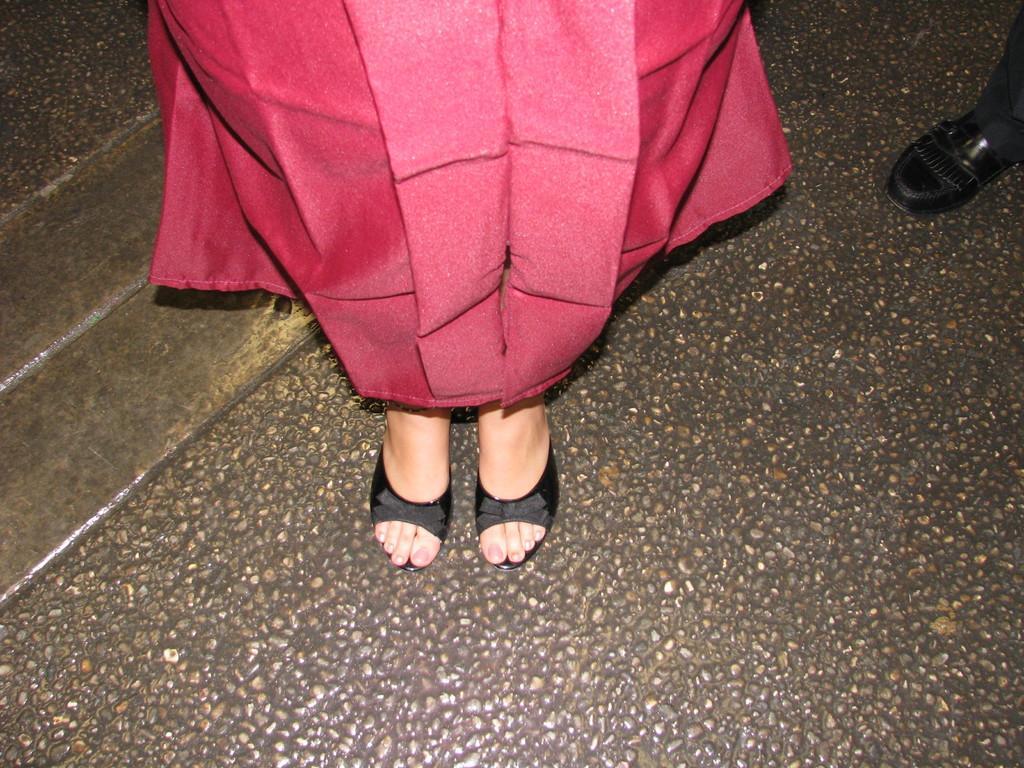Please provide a concise description of this image. In the center of the image, we can see legs of a person wearing red color dress and on the right, we can see shoe of a person. At the bottom, there is road. 